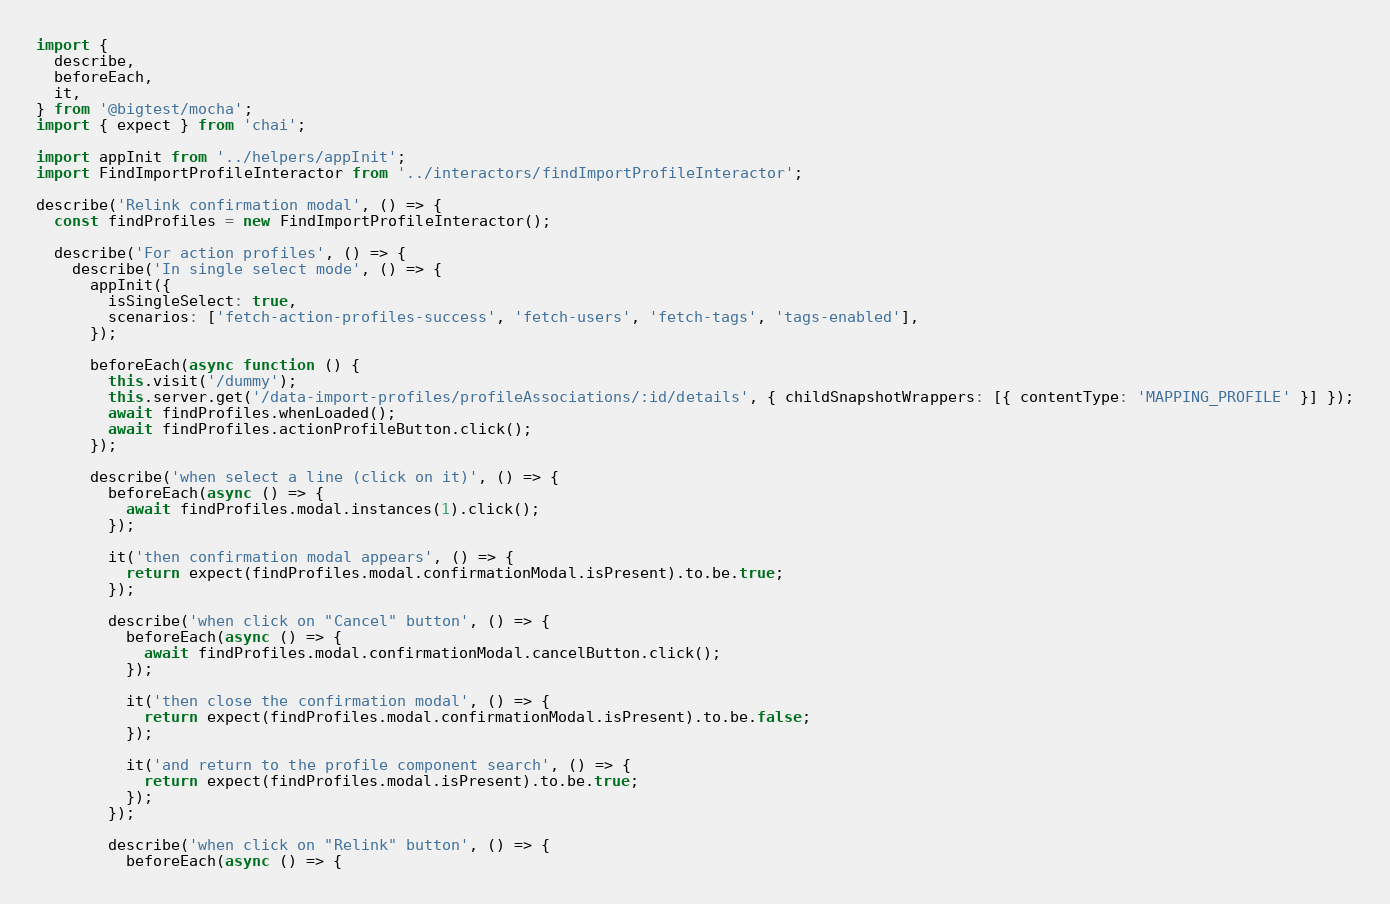Convert code to text. <code><loc_0><loc_0><loc_500><loc_500><_JavaScript_>import {
  describe,
  beforeEach,
  it,
} from '@bigtest/mocha';
import { expect } from 'chai';

import appInit from '../helpers/appInit';
import FindImportProfileInteractor from '../interactors/findImportProfileInteractor';

describe('Relink confirmation modal', () => {
  const findProfiles = new FindImportProfileInteractor();

  describe('For action profiles', () => {
    describe('In single select mode', () => {
      appInit({
        isSingleSelect: true,
        scenarios: ['fetch-action-profiles-success', 'fetch-users', 'fetch-tags', 'tags-enabled'],
      });

      beforeEach(async function () {
        this.visit('/dummy');
        this.server.get('/data-import-profiles/profileAssociations/:id/details', { childSnapshotWrappers: [{ contentType: 'MAPPING_PROFILE' }] });
        await findProfiles.whenLoaded();
        await findProfiles.actionProfileButton.click();
      });

      describe('when select a line (click on it)', () => {
        beforeEach(async () => {
          await findProfiles.modal.instances(1).click();
        });

        it('then confirmation modal appears', () => {
          return expect(findProfiles.modal.confirmationModal.isPresent).to.be.true;
        });

        describe('when click on "Cancel" button', () => {
          beforeEach(async () => {
            await findProfiles.modal.confirmationModal.cancelButton.click();
          });

          it('then close the confirmation modal', () => {
            return expect(findProfiles.modal.confirmationModal.isPresent).to.be.false;
          });

          it('and return to the profile component search', () => {
            return expect(findProfiles.modal.isPresent).to.be.true;
          });
        });

        describe('when click on "Relink" button', () => {
          beforeEach(async () => {</code> 